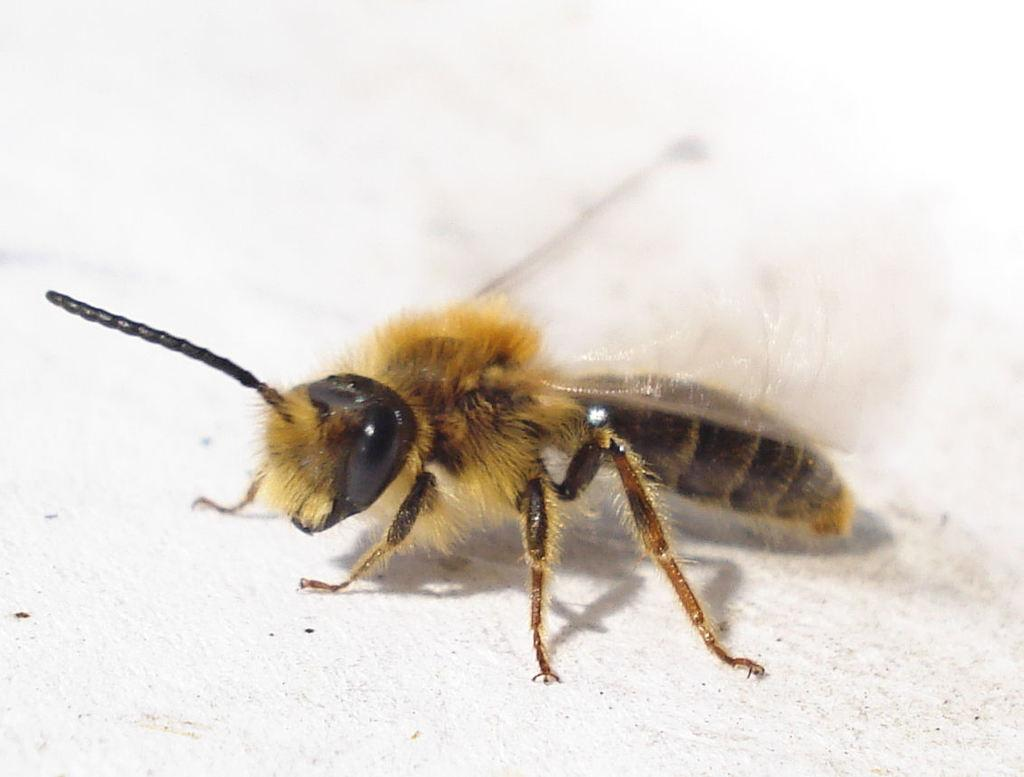What type of creature is in the picture? There is an insect in the picture. What is the color of the insect? The insect has a gold color. Does the insect have any specific features? Yes, the insect has wings. What type of skin can be seen on the insect in the image? There is no skin visible on the insect in the image, as insects have exoskeletons rather than skin. 